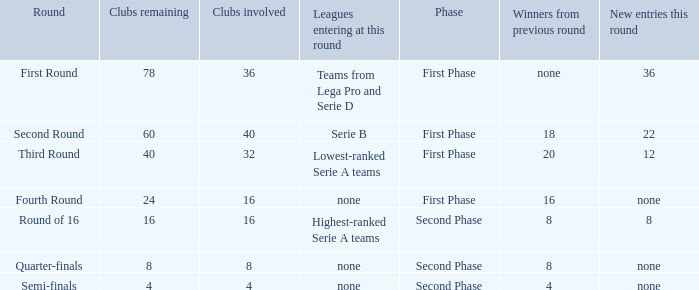From the round name of third round; what would the new entries this round that would be found? 12.0. 